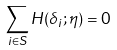<formula> <loc_0><loc_0><loc_500><loc_500>\sum _ { i \in S } H ( \delta _ { i } ; \eta ) = 0</formula> 